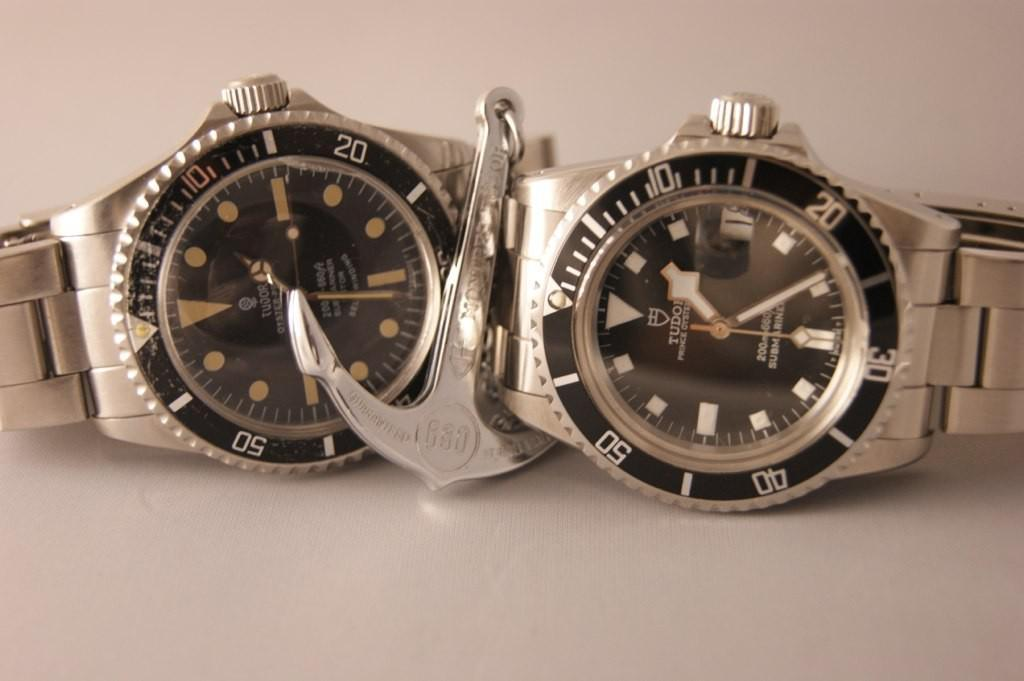<image>
Render a clear and concise summary of the photo. Two watches next to one another with one saying TUDOR on it. 